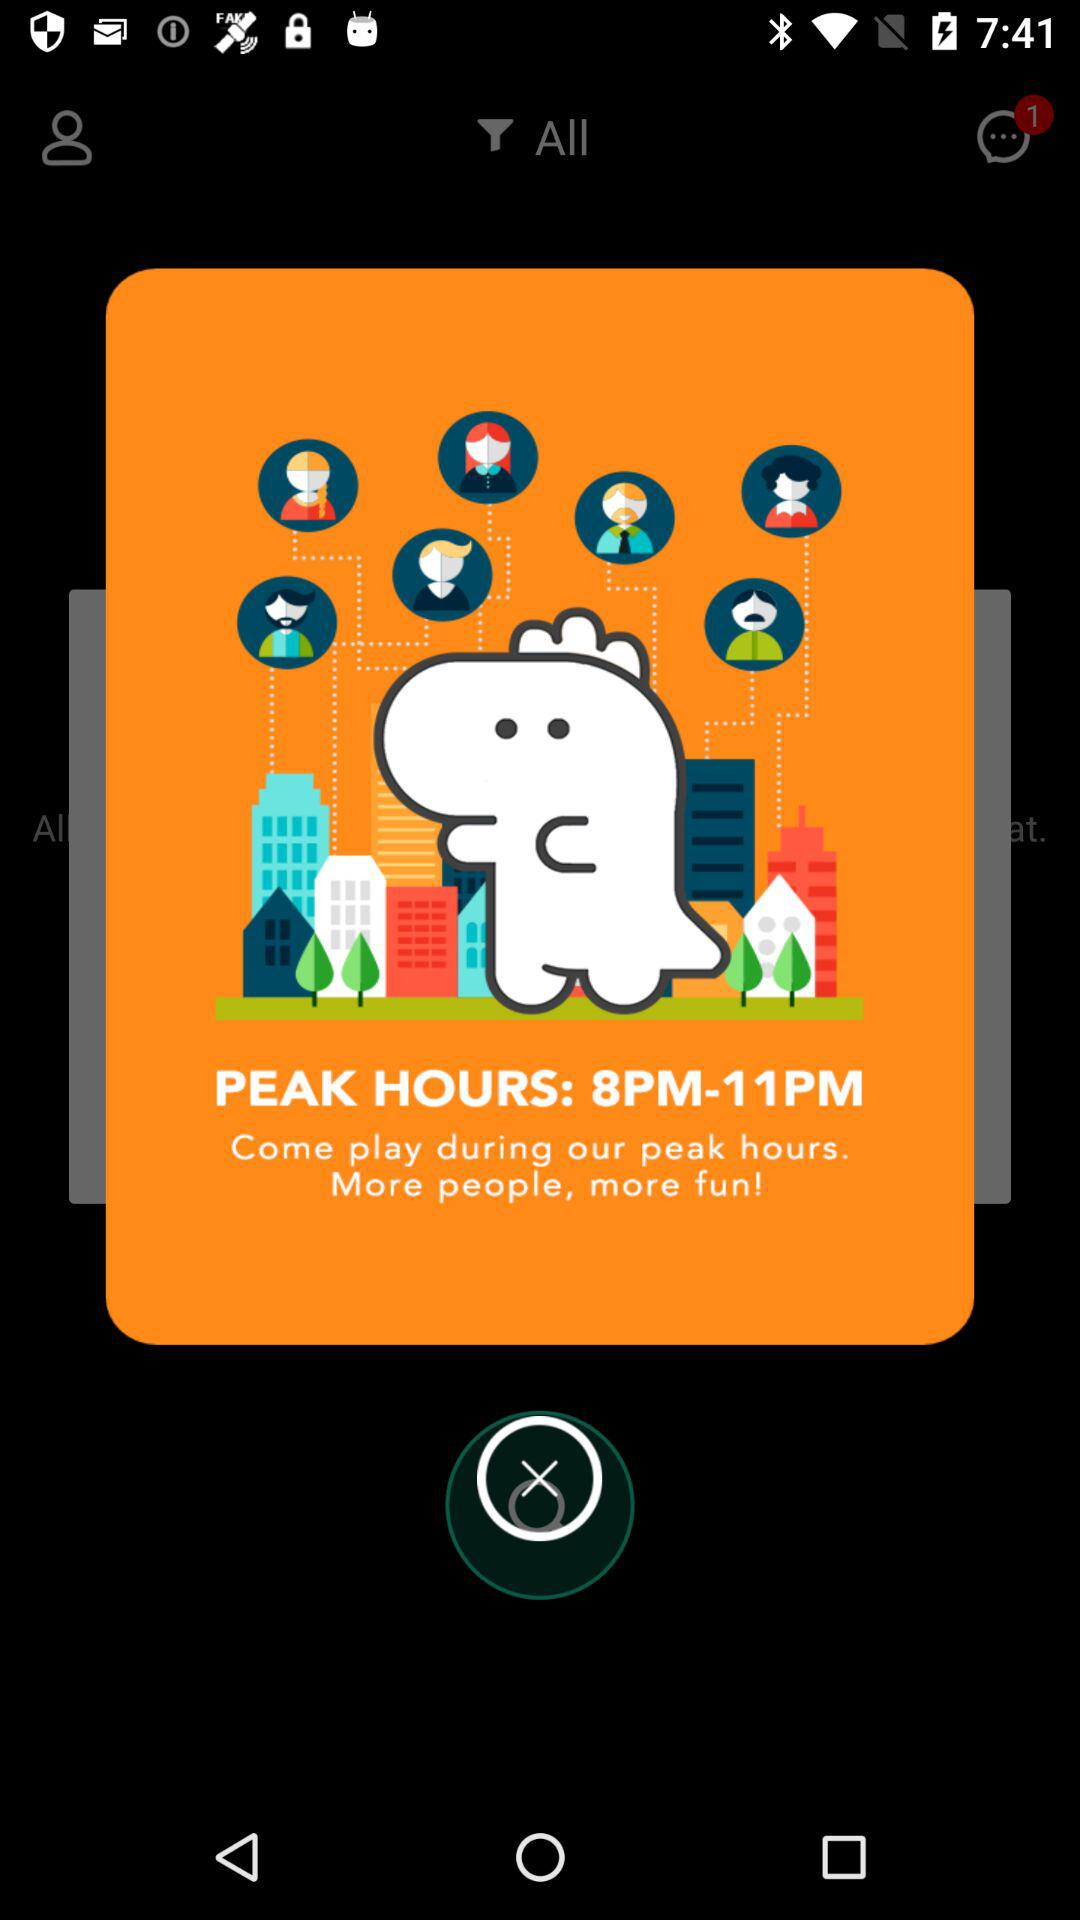What are the peak hours? The peak hours are from 8 PM to 11 PM. 